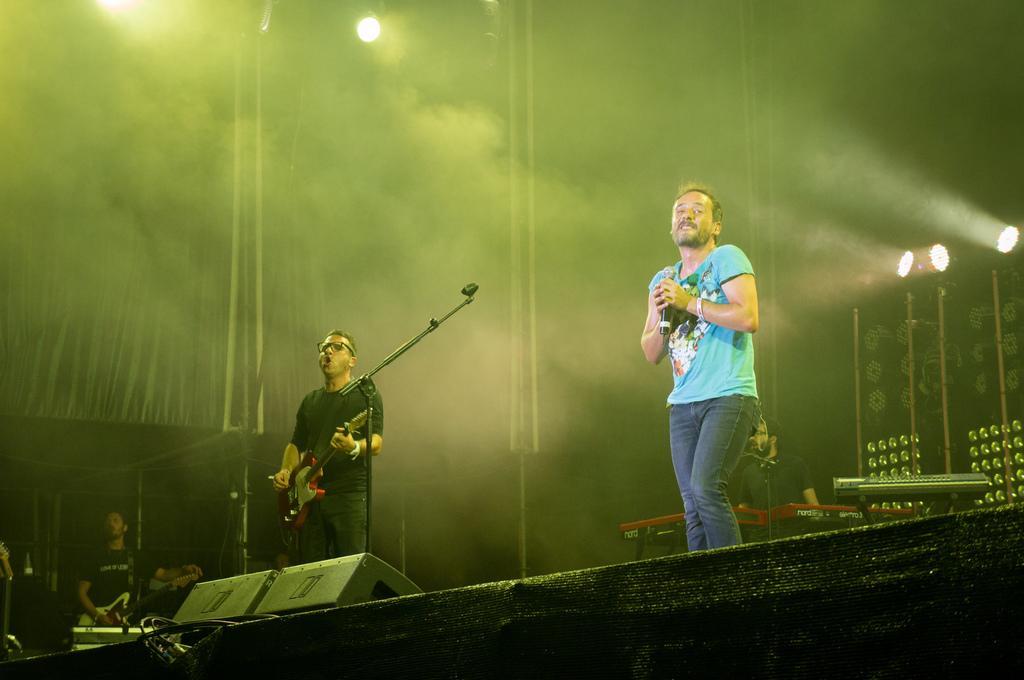Can you describe this image briefly? In this image we can see two people standing and holding guitars. On the right there is a man standing and holding a mic. At the bottom there are speakers. In the background there are lights and we can see a piano. There is a person standing. There are curtains. 